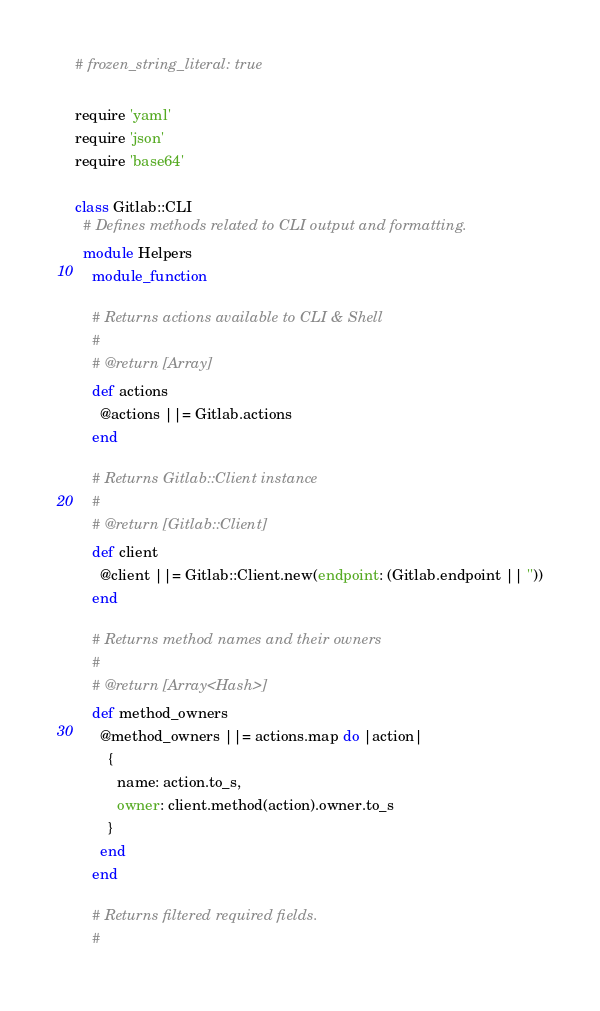Convert code to text. <code><loc_0><loc_0><loc_500><loc_500><_Ruby_># frozen_string_literal: true

require 'yaml'
require 'json'
require 'base64'

class Gitlab::CLI
  # Defines methods related to CLI output and formatting.
  module Helpers
    module_function

    # Returns actions available to CLI & Shell
    #
    # @return [Array]
    def actions
      @actions ||= Gitlab.actions
    end

    # Returns Gitlab::Client instance
    #
    # @return [Gitlab::Client]
    def client
      @client ||= Gitlab::Client.new(endpoint: (Gitlab.endpoint || ''))
    end

    # Returns method names and their owners
    #
    # @return [Array<Hash>]
    def method_owners
      @method_owners ||= actions.map do |action|
        {
          name: action.to_s,
          owner: client.method(action).owner.to_s
        }
      end
    end

    # Returns filtered required fields.
    #</code> 